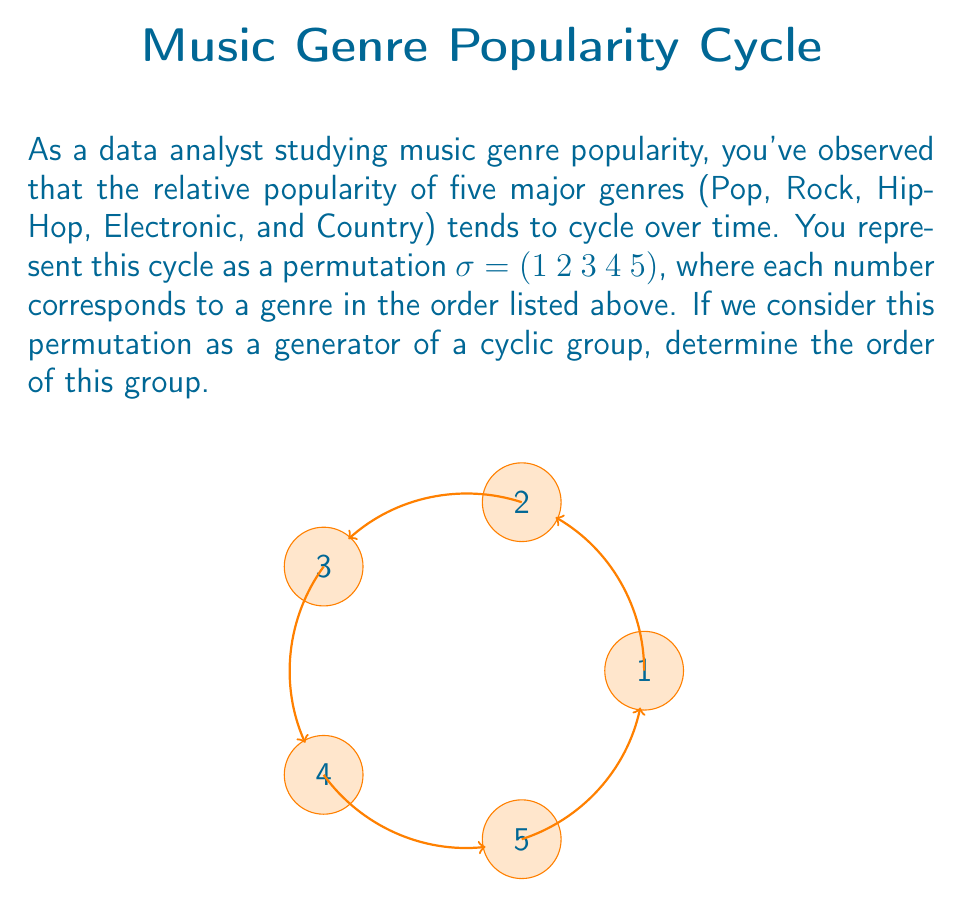Solve this math problem. Let's approach this step-by-step:

1) In group theory, the order of an element in a group is the smallest positive integer $n$ such that $\sigma^n = e$, where $e$ is the identity element.

2) For a cyclic permutation of $n$ elements, the order is always $n$. This is because it takes $n$ applications of the permutation to return to the original arrangement.

3) In this case, we have a cyclic permutation of 5 elements:
   $\sigma = (1\ 2\ 3\ 4\ 5)$

4) Let's see what happens when we apply $\sigma$ multiple times:
   $\sigma^1 = (1\ 2\ 3\ 4\ 5)$
   $\sigma^2 = (1\ 3\ 5\ 2\ 4)$
   $\sigma^3 = (1\ 4\ 2\ 5\ 3)$
   $\sigma^4 = (1\ 5\ 4\ 3\ 2)$
   $\sigma^5 = (1)(2)(3)(4)(5) = e$

5) We can see that it takes 5 applications of $\sigma$ to return to the identity permutation.

6) Therefore, the order of the cyclic group generated by $\sigma$ is 5.

This means that the popularity cycle of these music genres would theoretically repeat every 5 time periods in your model.
Answer: 5 